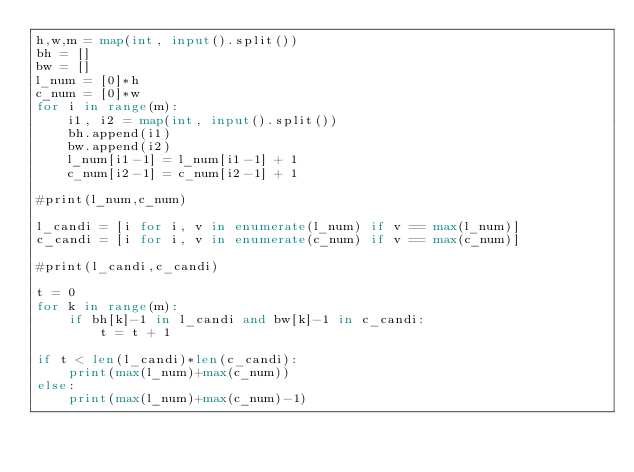Convert code to text. <code><loc_0><loc_0><loc_500><loc_500><_Python_>h,w,m = map(int, input().split())
bh = []
bw = []
l_num = [0]*h
c_num = [0]*w
for i in range(m):
    i1, i2 = map(int, input().split())
    bh.append(i1)
    bw.append(i2)
    l_num[i1-1] = l_num[i1-1] + 1
    c_num[i2-1] = c_num[i2-1] + 1

#print(l_num,c_num)

l_candi = [i for i, v in enumerate(l_num) if v == max(l_num)]
c_candi = [i for i, v in enumerate(c_num) if v == max(c_num)]

#print(l_candi,c_candi)

t = 0
for k in range(m):
    if bh[k]-1 in l_candi and bw[k]-1 in c_candi:
        t = t + 1

if t < len(l_candi)*len(c_candi):
    print(max(l_num)+max(c_num))
else:
    print(max(l_num)+max(c_num)-1)
</code> 